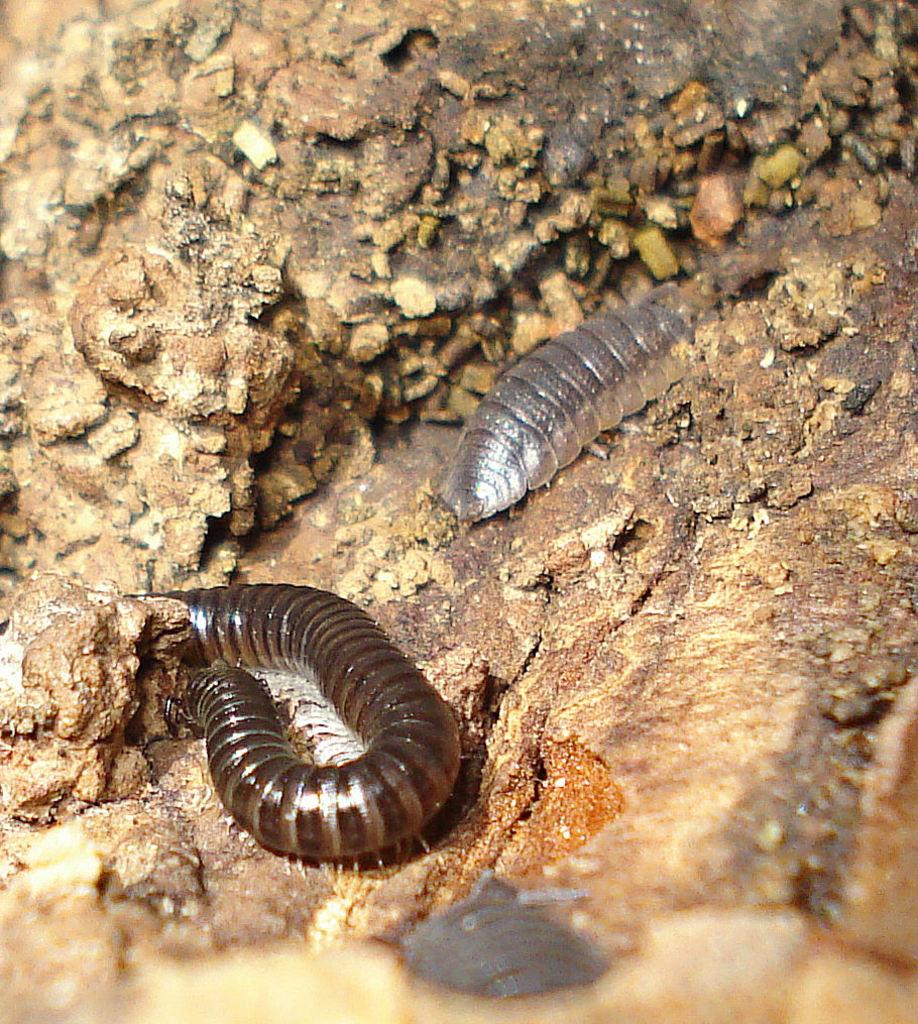What type of creatures can be seen on the ground in the image? There are insects on the ground in the image. What type of harmony can be heard in the image? There is no sound or music present in the image, so it is not possible to determine what type of harmony might be heard. 